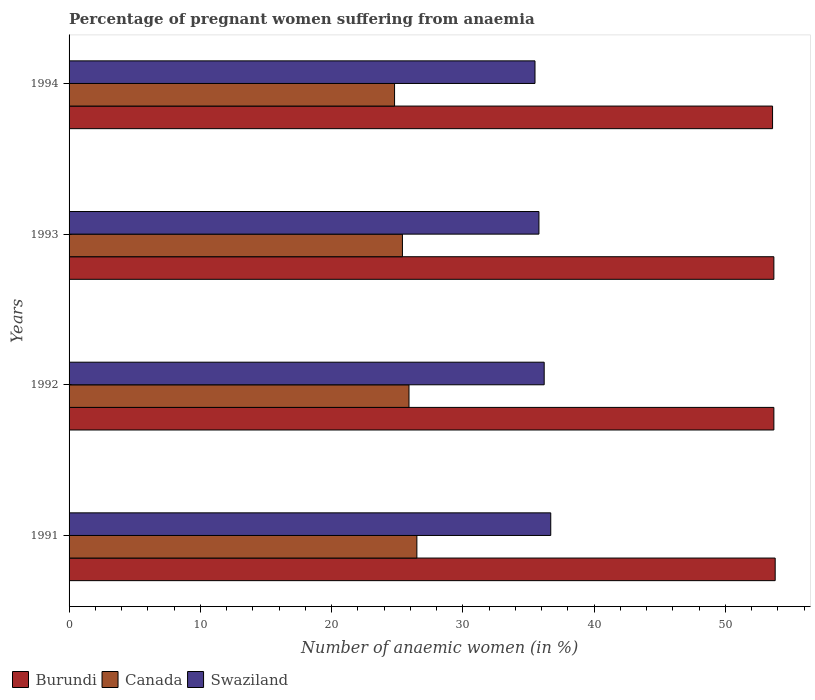How many different coloured bars are there?
Make the answer very short. 3. How many groups of bars are there?
Keep it short and to the point. 4. Are the number of bars on each tick of the Y-axis equal?
Your answer should be very brief. Yes. How many bars are there on the 1st tick from the top?
Ensure brevity in your answer.  3. How many bars are there on the 2nd tick from the bottom?
Your answer should be very brief. 3. In how many cases, is the number of bars for a given year not equal to the number of legend labels?
Offer a very short reply. 0. What is the number of anaemic women in Burundi in 1993?
Your answer should be very brief. 53.7. Across all years, what is the maximum number of anaemic women in Burundi?
Ensure brevity in your answer.  53.8. Across all years, what is the minimum number of anaemic women in Canada?
Your response must be concise. 24.8. In which year was the number of anaemic women in Swaziland maximum?
Your answer should be compact. 1991. In which year was the number of anaemic women in Burundi minimum?
Make the answer very short. 1994. What is the total number of anaemic women in Burundi in the graph?
Offer a very short reply. 214.8. What is the difference between the number of anaemic women in Swaziland in 1992 and that in 1993?
Your response must be concise. 0.4. What is the difference between the number of anaemic women in Swaziland in 1994 and the number of anaemic women in Burundi in 1992?
Provide a short and direct response. -18.2. What is the average number of anaemic women in Canada per year?
Offer a very short reply. 25.65. In the year 1991, what is the difference between the number of anaemic women in Swaziland and number of anaemic women in Canada?
Your answer should be compact. 10.2. What is the ratio of the number of anaemic women in Canada in 1992 to that in 1993?
Your response must be concise. 1.02. Is the number of anaemic women in Burundi in 1992 less than that in 1993?
Offer a terse response. No. Is the difference between the number of anaemic women in Swaziland in 1991 and 1992 greater than the difference between the number of anaemic women in Canada in 1991 and 1992?
Keep it short and to the point. No. What is the difference between the highest and the lowest number of anaemic women in Burundi?
Keep it short and to the point. 0.2. In how many years, is the number of anaemic women in Canada greater than the average number of anaemic women in Canada taken over all years?
Give a very brief answer. 2. What does the 3rd bar from the top in 1992 represents?
Your answer should be very brief. Burundi. What does the 3rd bar from the bottom in 1991 represents?
Provide a short and direct response. Swaziland. How many bars are there?
Your answer should be very brief. 12. How many years are there in the graph?
Offer a terse response. 4. What is the difference between two consecutive major ticks on the X-axis?
Your answer should be compact. 10. Are the values on the major ticks of X-axis written in scientific E-notation?
Keep it short and to the point. No. Does the graph contain grids?
Offer a very short reply. No. Where does the legend appear in the graph?
Provide a succinct answer. Bottom left. How many legend labels are there?
Provide a short and direct response. 3. How are the legend labels stacked?
Your response must be concise. Horizontal. What is the title of the graph?
Provide a short and direct response. Percentage of pregnant women suffering from anaemia. What is the label or title of the X-axis?
Offer a terse response. Number of anaemic women (in %). What is the label or title of the Y-axis?
Offer a very short reply. Years. What is the Number of anaemic women (in %) of Burundi in 1991?
Your answer should be compact. 53.8. What is the Number of anaemic women (in %) in Canada in 1991?
Your answer should be compact. 26.5. What is the Number of anaemic women (in %) of Swaziland in 1991?
Ensure brevity in your answer.  36.7. What is the Number of anaemic women (in %) in Burundi in 1992?
Your answer should be compact. 53.7. What is the Number of anaemic women (in %) in Canada in 1992?
Make the answer very short. 25.9. What is the Number of anaemic women (in %) in Swaziland in 1992?
Offer a very short reply. 36.2. What is the Number of anaemic women (in %) in Burundi in 1993?
Offer a terse response. 53.7. What is the Number of anaemic women (in %) of Canada in 1993?
Make the answer very short. 25.4. What is the Number of anaemic women (in %) in Swaziland in 1993?
Offer a very short reply. 35.8. What is the Number of anaemic women (in %) of Burundi in 1994?
Your answer should be very brief. 53.6. What is the Number of anaemic women (in %) of Canada in 1994?
Provide a short and direct response. 24.8. What is the Number of anaemic women (in %) in Swaziland in 1994?
Your response must be concise. 35.5. Across all years, what is the maximum Number of anaemic women (in %) in Burundi?
Offer a terse response. 53.8. Across all years, what is the maximum Number of anaemic women (in %) in Canada?
Your response must be concise. 26.5. Across all years, what is the maximum Number of anaemic women (in %) of Swaziland?
Offer a very short reply. 36.7. Across all years, what is the minimum Number of anaemic women (in %) in Burundi?
Your answer should be compact. 53.6. Across all years, what is the minimum Number of anaemic women (in %) in Canada?
Give a very brief answer. 24.8. Across all years, what is the minimum Number of anaemic women (in %) of Swaziland?
Give a very brief answer. 35.5. What is the total Number of anaemic women (in %) in Burundi in the graph?
Keep it short and to the point. 214.8. What is the total Number of anaemic women (in %) of Canada in the graph?
Make the answer very short. 102.6. What is the total Number of anaemic women (in %) in Swaziland in the graph?
Your answer should be very brief. 144.2. What is the difference between the Number of anaemic women (in %) in Burundi in 1991 and that in 1993?
Your answer should be compact. 0.1. What is the difference between the Number of anaemic women (in %) in Canada in 1991 and that in 1993?
Give a very brief answer. 1.1. What is the difference between the Number of anaemic women (in %) of Swaziland in 1991 and that in 1993?
Keep it short and to the point. 0.9. What is the difference between the Number of anaemic women (in %) of Burundi in 1991 and that in 1994?
Offer a terse response. 0.2. What is the difference between the Number of anaemic women (in %) in Burundi in 1992 and that in 1993?
Provide a succinct answer. 0. What is the difference between the Number of anaemic women (in %) in Canada in 1992 and that in 1993?
Your response must be concise. 0.5. What is the difference between the Number of anaemic women (in %) in Swaziland in 1992 and that in 1993?
Make the answer very short. 0.4. What is the difference between the Number of anaemic women (in %) in Canada in 1992 and that in 1994?
Your answer should be very brief. 1.1. What is the difference between the Number of anaemic women (in %) in Swaziland in 1993 and that in 1994?
Your answer should be compact. 0.3. What is the difference between the Number of anaemic women (in %) in Burundi in 1991 and the Number of anaemic women (in %) in Canada in 1992?
Ensure brevity in your answer.  27.9. What is the difference between the Number of anaemic women (in %) in Burundi in 1991 and the Number of anaemic women (in %) in Canada in 1993?
Offer a very short reply. 28.4. What is the difference between the Number of anaemic women (in %) of Burundi in 1991 and the Number of anaemic women (in %) of Canada in 1994?
Provide a short and direct response. 29. What is the difference between the Number of anaemic women (in %) of Burundi in 1991 and the Number of anaemic women (in %) of Swaziland in 1994?
Your answer should be very brief. 18.3. What is the difference between the Number of anaemic women (in %) of Burundi in 1992 and the Number of anaemic women (in %) of Canada in 1993?
Give a very brief answer. 28.3. What is the difference between the Number of anaemic women (in %) of Canada in 1992 and the Number of anaemic women (in %) of Swaziland in 1993?
Offer a terse response. -9.9. What is the difference between the Number of anaemic women (in %) of Burundi in 1992 and the Number of anaemic women (in %) of Canada in 1994?
Provide a succinct answer. 28.9. What is the difference between the Number of anaemic women (in %) of Canada in 1992 and the Number of anaemic women (in %) of Swaziland in 1994?
Make the answer very short. -9.6. What is the difference between the Number of anaemic women (in %) of Burundi in 1993 and the Number of anaemic women (in %) of Canada in 1994?
Your answer should be very brief. 28.9. What is the difference between the Number of anaemic women (in %) of Burundi in 1993 and the Number of anaemic women (in %) of Swaziland in 1994?
Ensure brevity in your answer.  18.2. What is the average Number of anaemic women (in %) of Burundi per year?
Your answer should be very brief. 53.7. What is the average Number of anaemic women (in %) in Canada per year?
Make the answer very short. 25.65. What is the average Number of anaemic women (in %) of Swaziland per year?
Ensure brevity in your answer.  36.05. In the year 1991, what is the difference between the Number of anaemic women (in %) of Burundi and Number of anaemic women (in %) of Canada?
Give a very brief answer. 27.3. In the year 1992, what is the difference between the Number of anaemic women (in %) of Burundi and Number of anaemic women (in %) of Canada?
Ensure brevity in your answer.  27.8. In the year 1992, what is the difference between the Number of anaemic women (in %) in Burundi and Number of anaemic women (in %) in Swaziland?
Make the answer very short. 17.5. In the year 1992, what is the difference between the Number of anaemic women (in %) of Canada and Number of anaemic women (in %) of Swaziland?
Your answer should be very brief. -10.3. In the year 1993, what is the difference between the Number of anaemic women (in %) in Burundi and Number of anaemic women (in %) in Canada?
Keep it short and to the point. 28.3. In the year 1994, what is the difference between the Number of anaemic women (in %) of Burundi and Number of anaemic women (in %) of Canada?
Make the answer very short. 28.8. What is the ratio of the Number of anaemic women (in %) of Canada in 1991 to that in 1992?
Your answer should be very brief. 1.02. What is the ratio of the Number of anaemic women (in %) of Swaziland in 1991 to that in 1992?
Provide a succinct answer. 1.01. What is the ratio of the Number of anaemic women (in %) in Burundi in 1991 to that in 1993?
Keep it short and to the point. 1. What is the ratio of the Number of anaemic women (in %) in Canada in 1991 to that in 1993?
Make the answer very short. 1.04. What is the ratio of the Number of anaemic women (in %) in Swaziland in 1991 to that in 1993?
Ensure brevity in your answer.  1.03. What is the ratio of the Number of anaemic women (in %) of Burundi in 1991 to that in 1994?
Make the answer very short. 1. What is the ratio of the Number of anaemic women (in %) of Canada in 1991 to that in 1994?
Offer a very short reply. 1.07. What is the ratio of the Number of anaemic women (in %) of Swaziland in 1991 to that in 1994?
Offer a very short reply. 1.03. What is the ratio of the Number of anaemic women (in %) in Burundi in 1992 to that in 1993?
Provide a succinct answer. 1. What is the ratio of the Number of anaemic women (in %) of Canada in 1992 to that in 1993?
Provide a succinct answer. 1.02. What is the ratio of the Number of anaemic women (in %) in Swaziland in 1992 to that in 1993?
Keep it short and to the point. 1.01. What is the ratio of the Number of anaemic women (in %) of Canada in 1992 to that in 1994?
Give a very brief answer. 1.04. What is the ratio of the Number of anaemic women (in %) in Swaziland in 1992 to that in 1994?
Provide a short and direct response. 1.02. What is the ratio of the Number of anaemic women (in %) in Burundi in 1993 to that in 1994?
Offer a very short reply. 1. What is the ratio of the Number of anaemic women (in %) in Canada in 1993 to that in 1994?
Provide a short and direct response. 1.02. What is the ratio of the Number of anaemic women (in %) in Swaziland in 1993 to that in 1994?
Keep it short and to the point. 1.01. What is the difference between the highest and the second highest Number of anaemic women (in %) of Swaziland?
Offer a terse response. 0.5. What is the difference between the highest and the lowest Number of anaemic women (in %) of Burundi?
Provide a succinct answer. 0.2. What is the difference between the highest and the lowest Number of anaemic women (in %) of Swaziland?
Your answer should be very brief. 1.2. 